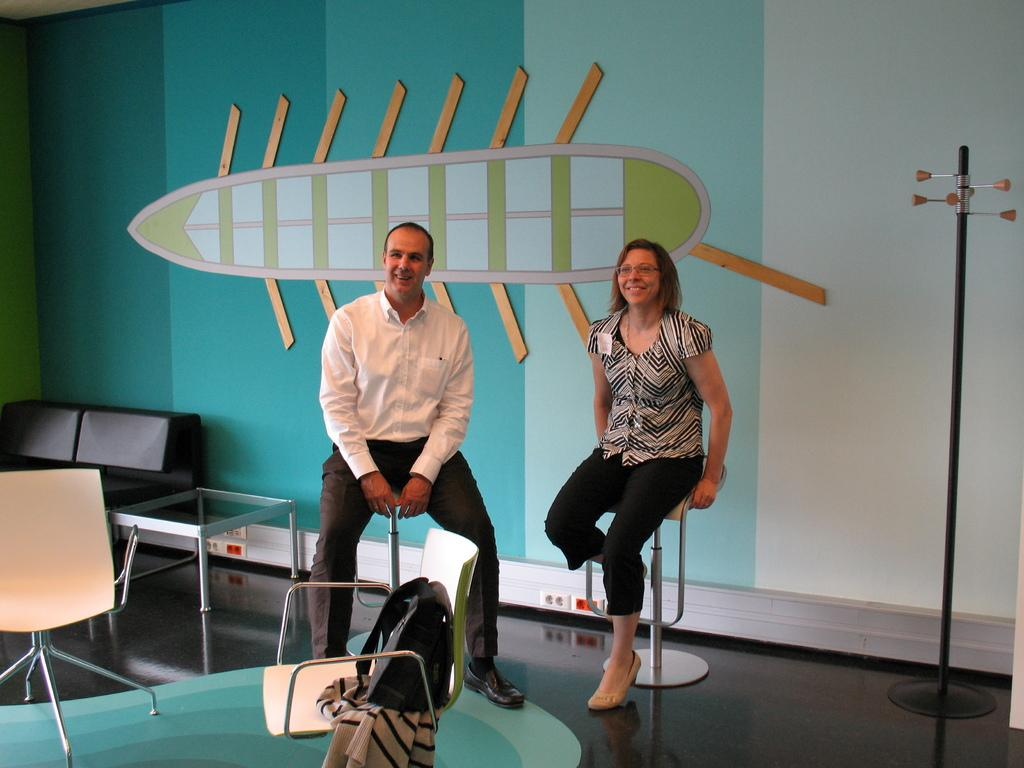How many people are present in the image? There are two people in the image. What are the people doing in the image? The people are sitting on stools. What is the furniture piece located between the two people? There is a table in the image. What type of seating is available for additional people? There are two chairs in the image. What type of art can be seen hanging on the wall behind the people in the image? There is no art visible in the image; it only shows two people sitting on stools with a table between them. 